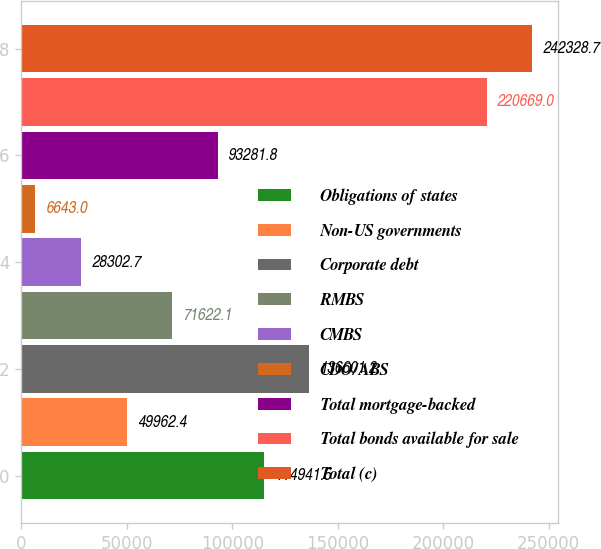Convert chart. <chart><loc_0><loc_0><loc_500><loc_500><bar_chart><fcel>Obligations of states<fcel>Non-US governments<fcel>Corporate debt<fcel>RMBS<fcel>CMBS<fcel>CDO/ABS<fcel>Total mortgage-backed<fcel>Total bonds available for sale<fcel>Total (c)<nl><fcel>114942<fcel>49962.4<fcel>136601<fcel>71622.1<fcel>28302.7<fcel>6643<fcel>93281.8<fcel>220669<fcel>242329<nl></chart> 